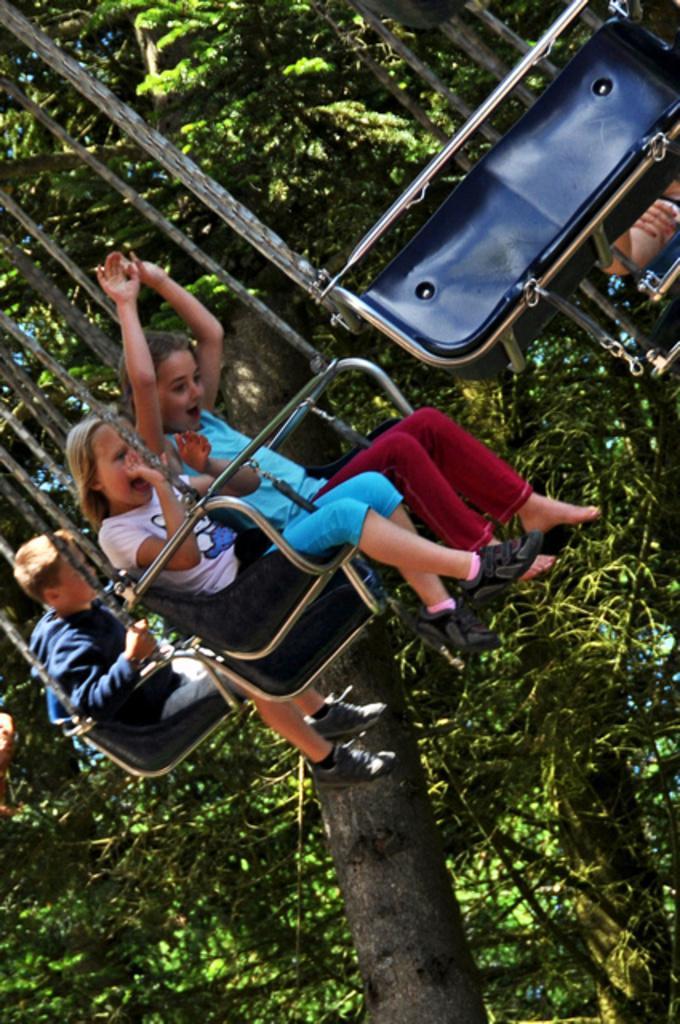Can you describe this image briefly? In this image there are three kids taking amusement ride, in the background there are trees. 